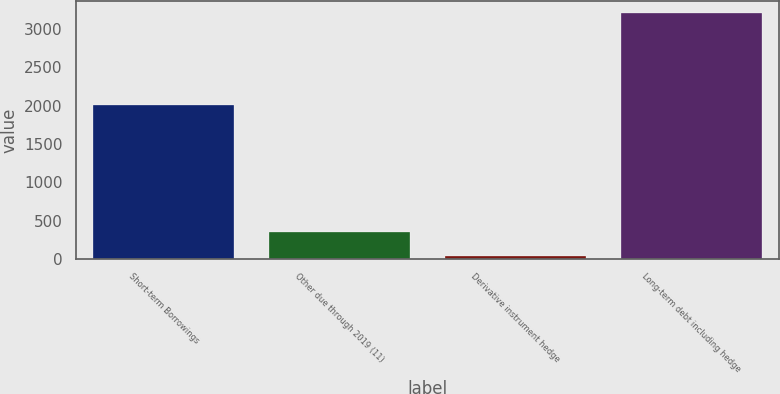Convert chart to OTSL. <chart><loc_0><loc_0><loc_500><loc_500><bar_chart><fcel>Short-term Borrowings<fcel>Other due through 2019 (11)<fcel>Derivative instrument hedge<fcel>Long-term debt including hedge<nl><fcel>2009<fcel>353.1<fcel>36<fcel>3207<nl></chart> 